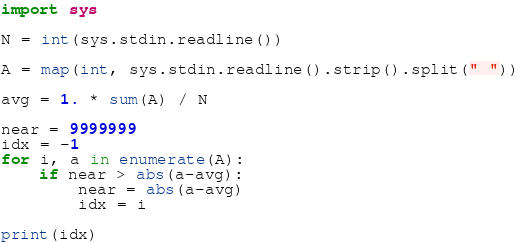<code> <loc_0><loc_0><loc_500><loc_500><_Python_>import sys

N = int(sys.stdin.readline())

A = map(int, sys.stdin.readline().strip().split(" "))

avg = 1. * sum(A) / N

near = 9999999
idx = -1
for i, a in enumerate(A):
    if near > abs(a-avg):
        near = abs(a-avg)
        idx = i

print(idx)
</code> 